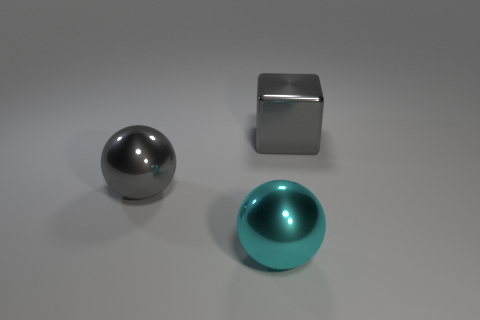Does the large gray thing that is on the left side of the cyan shiny ball have the same material as the big gray cube?
Ensure brevity in your answer.  Yes. Are there an equal number of gray objects in front of the block and large gray objects?
Your answer should be compact. No. There is a ball that is the same color as the large block; what is it made of?
Provide a succinct answer. Metal. What number of other blocks have the same color as the large cube?
Your answer should be compact. 0. There is a object to the left of the shiny sphere that is on the right side of the big gray sphere; how big is it?
Provide a succinct answer. Large. There is a cube; is its color the same as the large metallic thing that is left of the cyan metal ball?
Your answer should be compact. Yes. Is there another green block of the same size as the metallic block?
Offer a terse response. No. Is there a big shiny sphere that is in front of the big thing that is left of the cyan metallic object?
Offer a terse response. Yes. What is the color of the big shiny thing that is behind the cyan shiny ball and to the left of the big shiny cube?
Your answer should be very brief. Gray. How many big objects are cyan spheres or balls?
Offer a terse response. 2. 